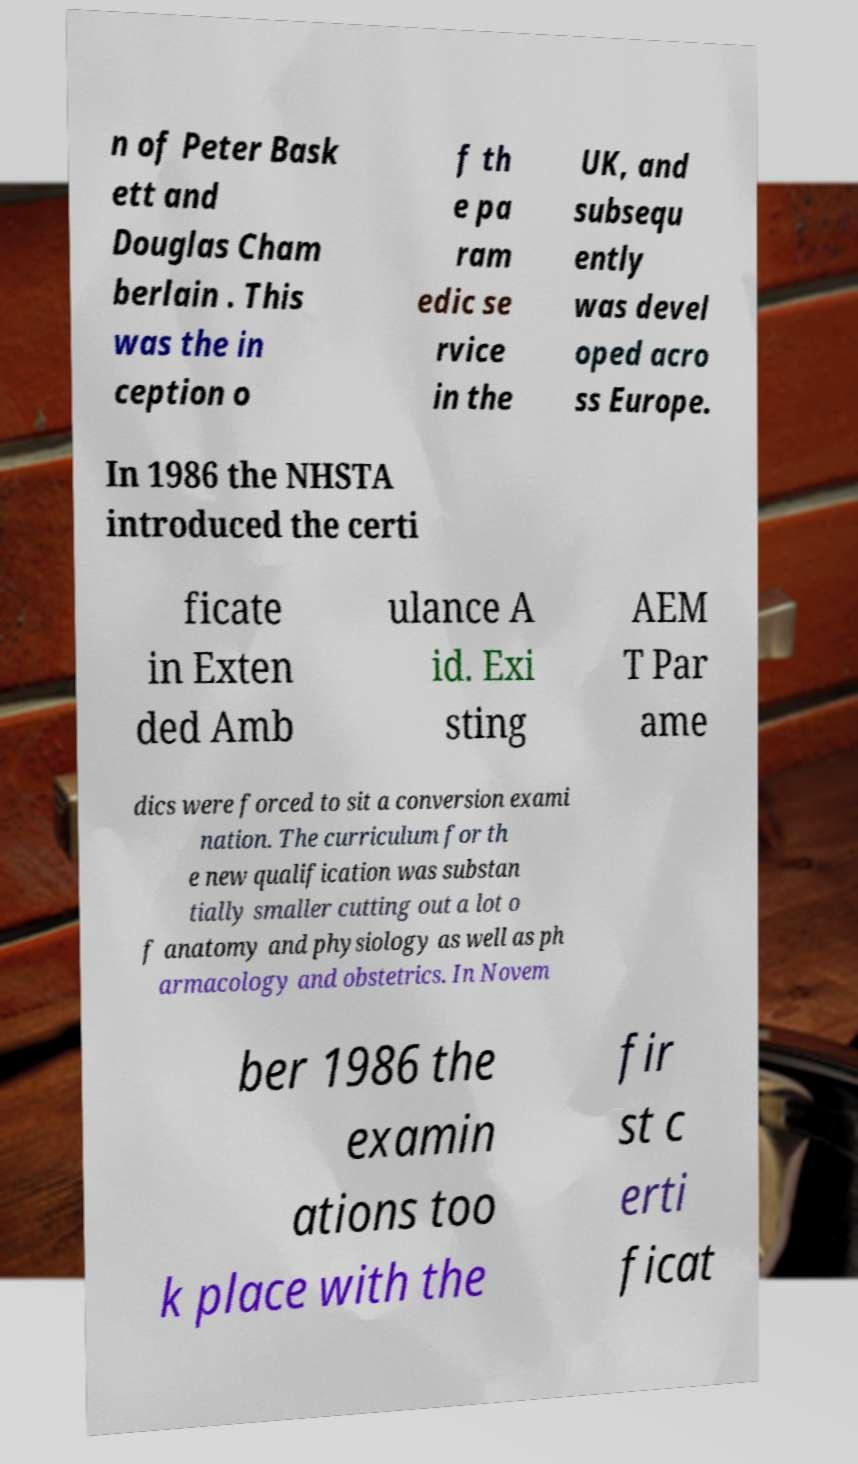Could you assist in decoding the text presented in this image and type it out clearly? n of Peter Bask ett and Douglas Cham berlain . This was the in ception o f th e pa ram edic se rvice in the UK, and subsequ ently was devel oped acro ss Europe. In 1986 the NHSTA introduced the certi ficate in Exten ded Amb ulance A id. Exi sting AEM T Par ame dics were forced to sit a conversion exami nation. The curriculum for th e new qualification was substan tially smaller cutting out a lot o f anatomy and physiology as well as ph armacology and obstetrics. In Novem ber 1986 the examin ations too k place with the fir st c erti ficat 